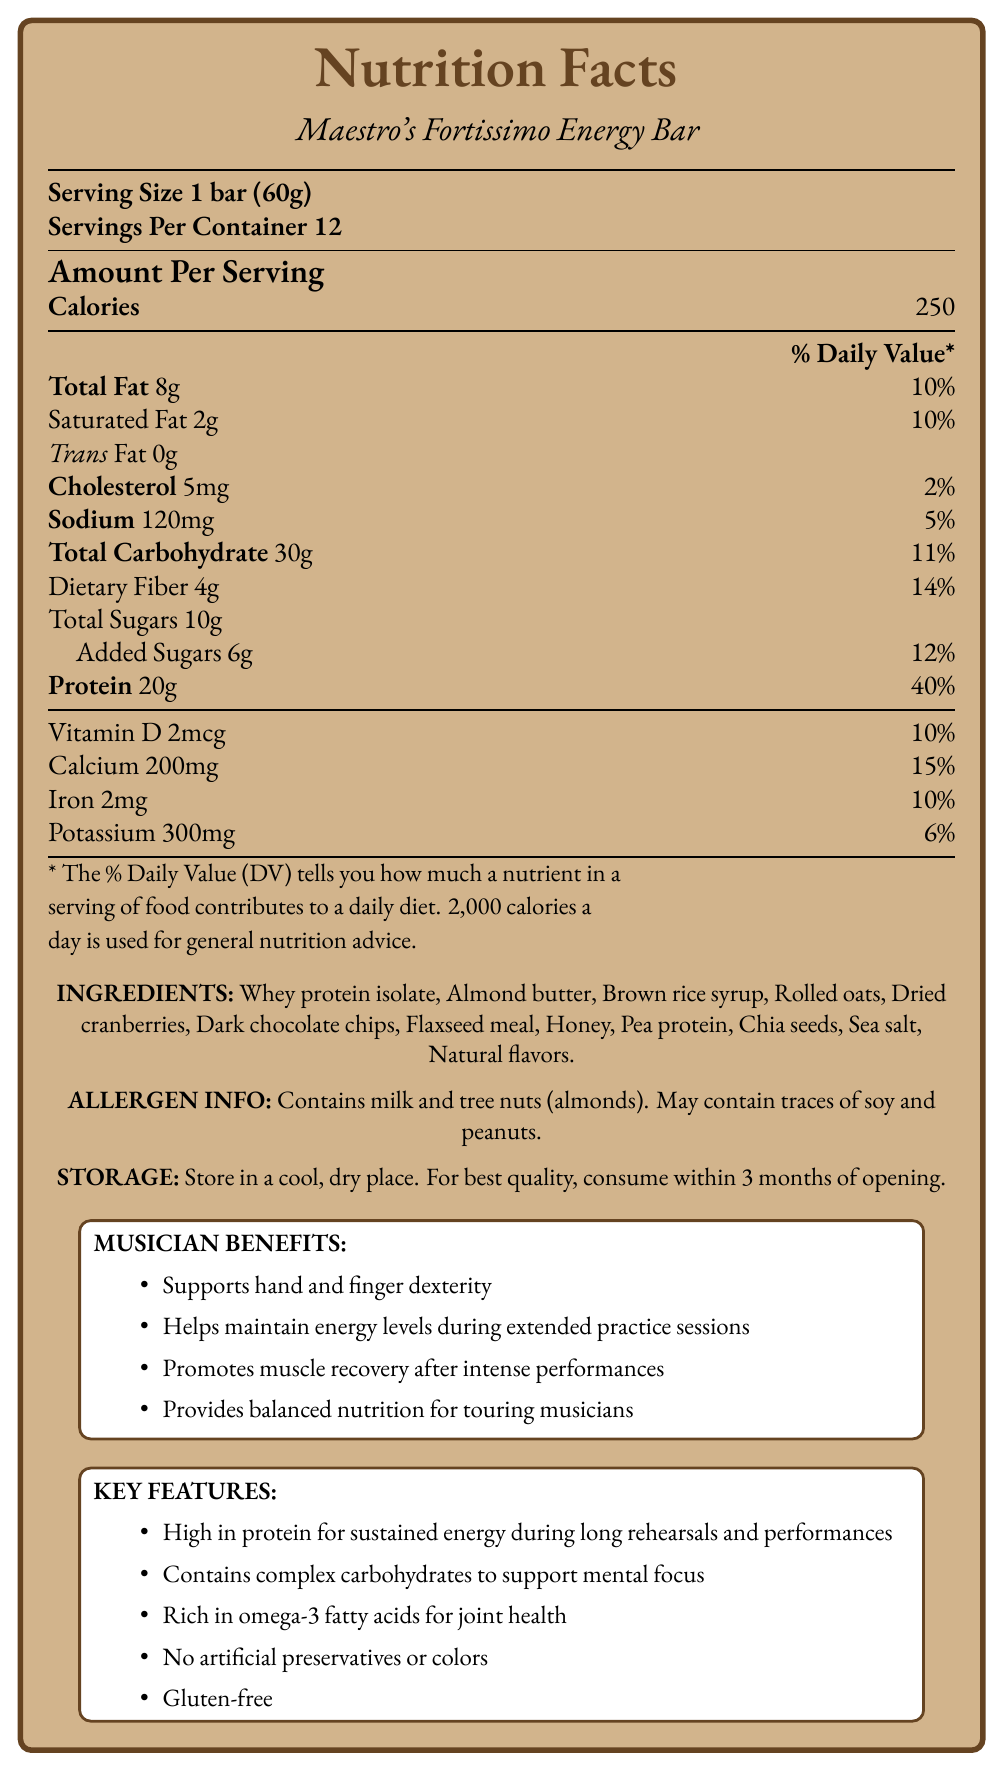what is the serving size of Maestro's Fortissimo Energy Bar? The document specifies that the serving size is 1 bar, which weighs 60 grams.
Answer: 1 bar (60g) how many bars are there in a container? The document indicates that there are 12 servings per container, and each serving size is 1 bar.
Answer: 12 how many calories are in one serving? The document mentions that each serving of the energy bar contains 250 calories.
Answer: 250 what is the total fat content per serving? The document lists the total fat content as 8 grams per serving.
Answer: 8g how much protein does each energy bar provide? The document states that each bar contains 20 grams of protein.
Answer: 20g what percentage of the daily value of calcium does one bar provide? The document states that one bar provides 15% of the daily value of calcium.
Answer: 15% what are the three main ingredients listed in the energy bar? A. Whey protein isolate, Honey, Sea salt B. Rolled oats, Whey protein isolate, Sea salt C. Whey protein isolate, Almond butter, Brown rice syrup D. Honey, Dark chocolate chips, Flaxseed meal The document lists the three main ingredients as Whey protein isolate, Almond butter, and Brown rice syrup.
Answer: C how many grams of dietary fiber does each serving contain? The document specifies that each serving contains 4 grams of dietary fiber.
Answer: 4g what is the primary claim about this energy bar in terms of its protein content? The document makes a claim that the energy bar is high in protein for sustained energy, which is beneficial during long rehearsals and performances.
Answer: High in protein for sustained energy during long rehearsals and performances how many milligrams of potassium are in one serving? The document indicates that each serving contains 300 milligrams of potassium.
Answer: 300mg is the product gluten-free? The document claims that the product is gluten-free.
Answer: Yes besides almonds, what other allergen is this product confirmed to contain? The document states that the product contains milk and tree nuts (almonds).
Answer: Milk given that 2,000 calories a day is used for recommendation, how many percent of daily value does a bar provide for carbohydrates? The document indicates that one bar provides 11% of the daily value for carbohydrates.
Answer: 11% which of the following is NOT listed under "musician benefits"? A. Boosts immune system B. Helps maintain energy levels during extended practice sessions C. Promotes muscle recovery after intense performances D. Supports hand and finger dexterity The document does not mention boosting the immune system as a benefit under "musician benefits.”
Answer: A does the product have any artificial preservatives or colors? The document claims that the product has no artificial preservatives or colors.
Answer: No when should you consume the product for best quality after opening? The document advises consuming the product within 3 months of opening for best quality.
Answer: Within 3 months summarize the main idea of the document. The document provides comprehensive nutritional information about an energy bar designed for musicians, highlighting its ingredients, allergen information, storage instructions, and the health benefits it offers, particularly for musicians.
Answer: The document is a nutrition facts label for Maestro's Fortissimo Energy Bar, emphasizing its high protein content and benefits for classical musicians. It details serving size, nutritional content, ingredients, allergens, storage instructions, and specific benefits for musicians, focusing on energy, focus, and muscle recovery. 